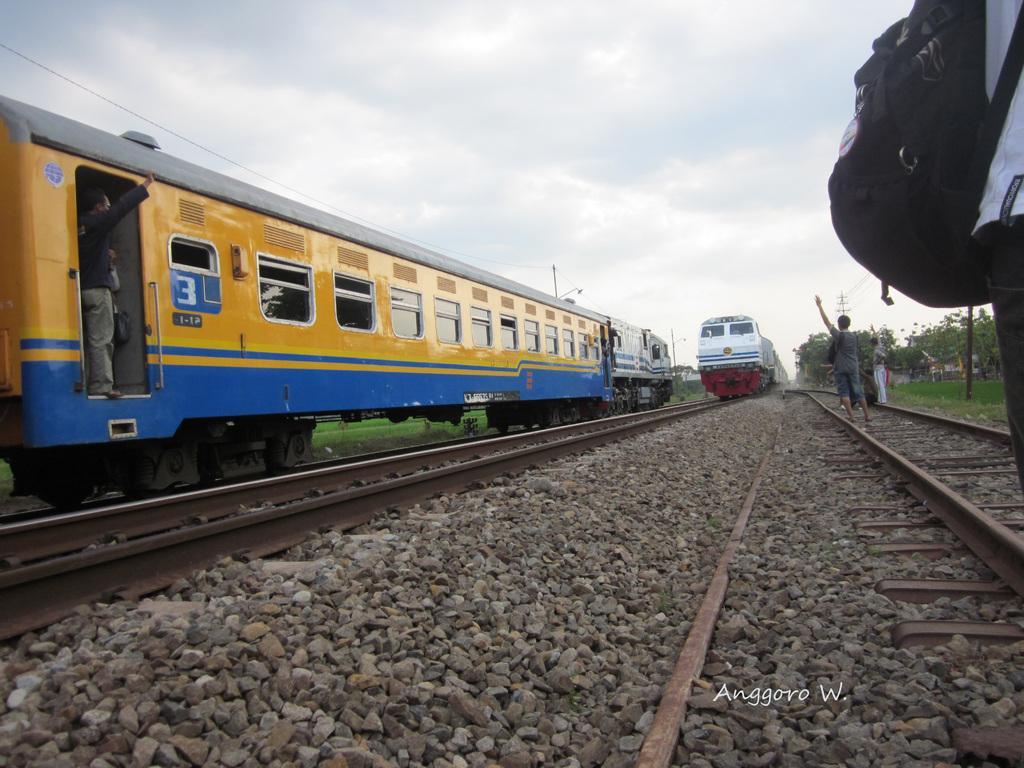Can you describe this image briefly? This is an outside view. Here I can see two trains on the railway tracks. At the bottom, I can see the stones on the ground. On the right side there are few people standing on the railway track, in the background there are some trees. Here I can see a person wearing a bag and standing. At the top of the image I can see the sky and clouds. 